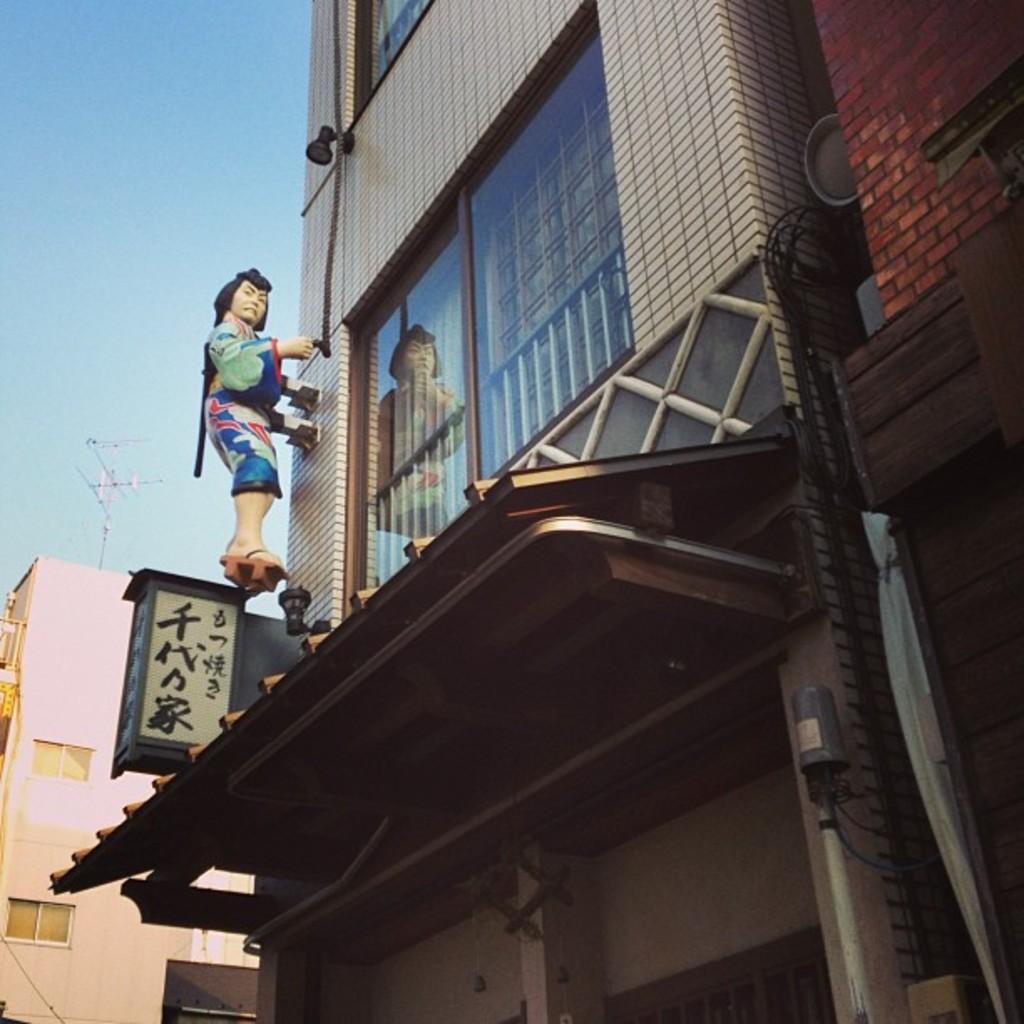Please provide a concise description of this image. In this image we can see few buildings. There are few objects on the wall. We can see the sky. There are few windows in the image. We can see a sculpture of a person. We can see the reflection of a person on the glass. There is an antenna at the left side of the image. There some text on the board. 